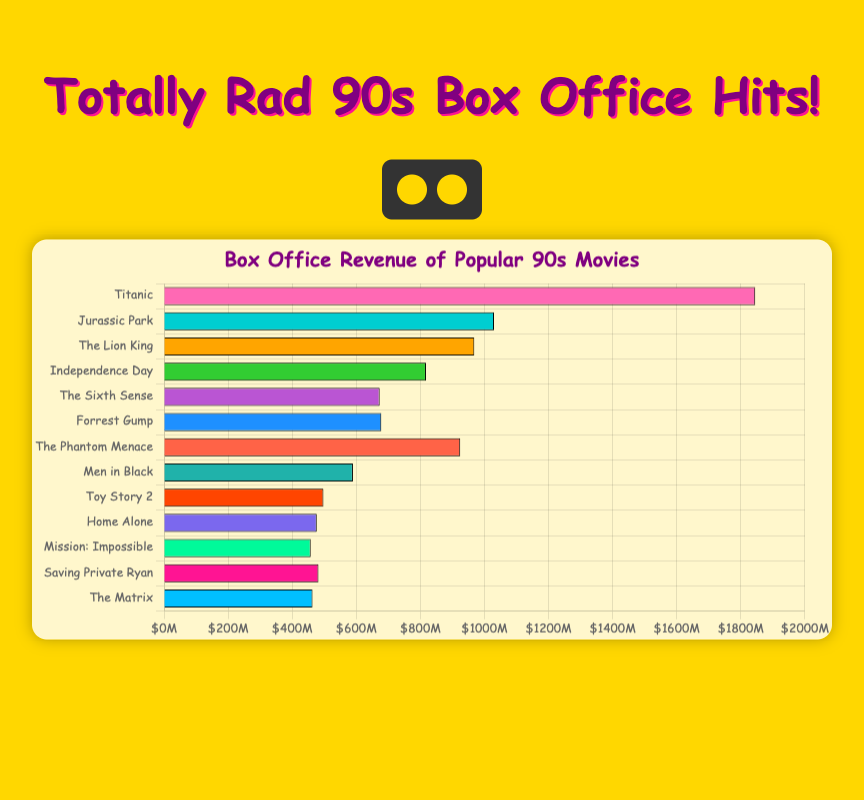Which movie has the highest box office revenue? The bar representing "Titanic" is the longest in the chart, indicating it has the highest box office revenue.
Answer: Titanic What is the total box office revenue for "The Lion King" and "The Phantom Menace"? Add the box office revenues of "The Lion King" ($968,483,777) and "The Phantom Menace" ($924,317,558). The sum is $1,892,801,335.
Answer: $1,892,801,335 How much more revenue did "Jurassic Park" make compared to "Home Alone"? Subtract the box office revenue of "Home Alone" ($476,684,675) from "Jurassic Park" ($1,029,876,754). The difference is $553,192,079.
Answer: $553,192,079 Which two movies have the closest revenues, and what are their values? "Forrest Gump" ($678,226,465) and "The Sixth Sense" ($672,806,292) have the closest revenues.
Answer: Forrest Gump and The Sixth Sense Among the top five box office movies, which one has the lowest revenue? Among the top five (Titanic, Jurassic Park, The Lion King, The Phantom Menace, Independence Day), "Independence Day" has the lowest bar, indicating it has the lowest revenue.
Answer: Independence Day Which movie has a box office revenue just under $500 million? The bar for "Toy Story 2" is just under the $500 million mark on the x-axis.
Answer: Toy Story 2 By how much does "Mission: Impossible" lag behind "Saving Private Ryan" in terms of box office revenue? Subtract the box office revenue of "Mission: Impossible" ($457,696,359) from "Saving Private Ryan" ($481,840,909). The difference is $24,144,550.
Answer: $24,144,550 What is the combined revenue of the two Steven Spielberg movies listed? Add the box office revenues of "Jurassic Park" ($1,029,876,754) and "Saving Private Ryan" ($481,840,909). The sum is $1,511,717,663.
Answer: $1,511,717,663 Which movie generated more revenue, "The Matrix" or "Home Alone"? "The Matrix" has a higher box office revenue bar than "Home Alone".
Answer: The Matrix 